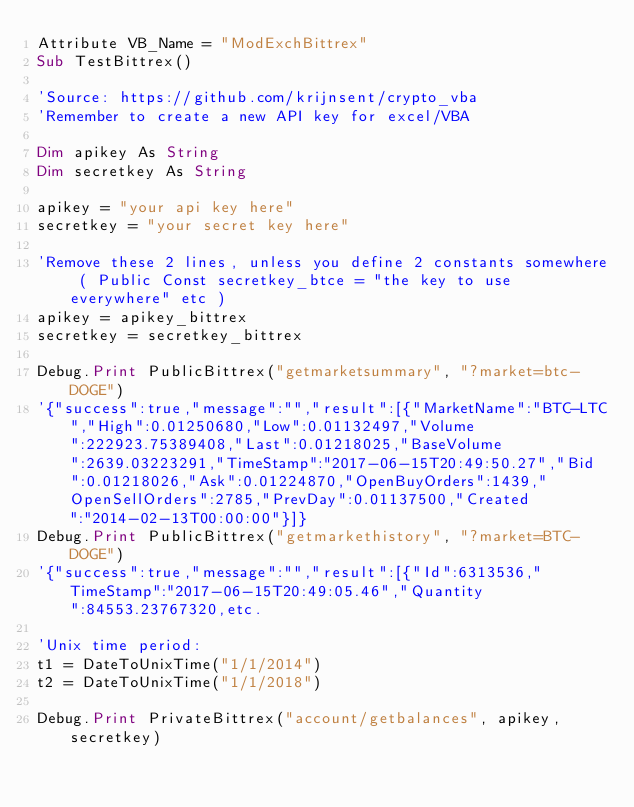<code> <loc_0><loc_0><loc_500><loc_500><_VisualBasic_>Attribute VB_Name = "ModExchBittrex"
Sub TestBittrex()

'Source: https://github.com/krijnsent/crypto_vba
'Remember to create a new API key for excel/VBA

Dim apikey As String
Dim secretkey As String

apikey = "your api key here"
secretkey = "your secret key here"

'Remove these 2 lines, unless you define 2 constants somewhere ( Public Const secretkey_btce = "the key to use everywhere" etc )
apikey = apikey_bittrex
secretkey = secretkey_bittrex

Debug.Print PublicBittrex("getmarketsummary", "?market=btc-DOGE")
'{"success":true,"message":"","result":[{"MarketName":"BTC-LTC","High":0.01250680,"Low":0.01132497,"Volume":222923.75389408,"Last":0.01218025,"BaseVolume":2639.03223291,"TimeStamp":"2017-06-15T20:49:50.27","Bid":0.01218026,"Ask":0.01224870,"OpenBuyOrders":1439,"OpenSellOrders":2785,"PrevDay":0.01137500,"Created":"2014-02-13T00:00:00"}]}
Debug.Print PublicBittrex("getmarkethistory", "?market=BTC-DOGE")
'{"success":true,"message":"","result":[{"Id":6313536,"TimeStamp":"2017-06-15T20:49:05.46","Quantity":84553.23767320,etc.

'Unix time period:
t1 = DateToUnixTime("1/1/2014")
t2 = DateToUnixTime("1/1/2018")

Debug.Print PrivateBittrex("account/getbalances", apikey, secretkey)</code> 